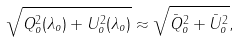<formula> <loc_0><loc_0><loc_500><loc_500>\sqrt { Q ^ { 2 } _ { o } ( \lambda _ { o } ) + U ^ { 2 } _ { o } ( \lambda _ { o } ) } \approx \sqrt { { \bar { Q } } ^ { 2 } _ { o } + { \bar { U } } ^ { 2 } _ { o } } ,</formula> 